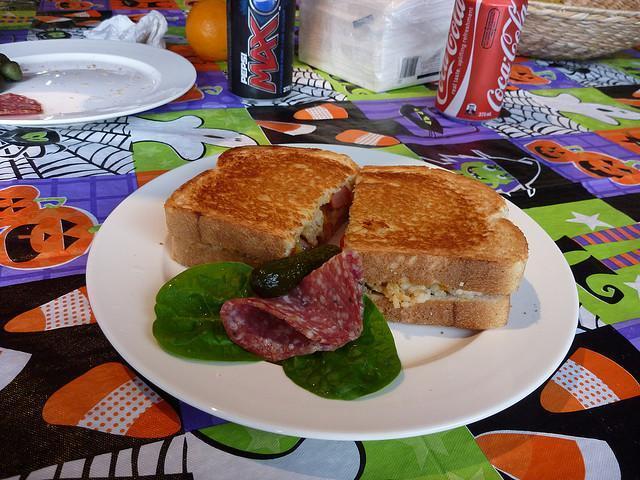How many train cars are on the right of the man ?
Give a very brief answer. 0. 